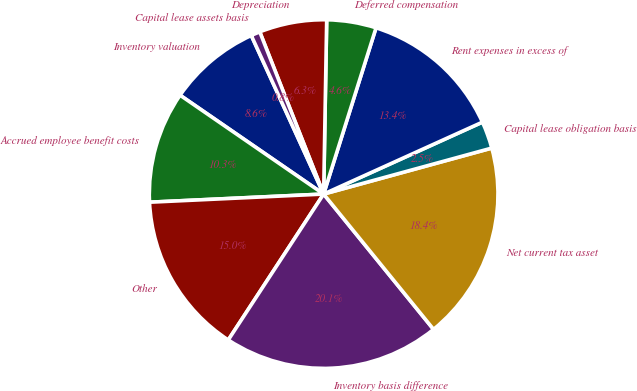<chart> <loc_0><loc_0><loc_500><loc_500><pie_chart><fcel>Inventory valuation<fcel>Accrued employee benefit costs<fcel>Other<fcel>Inventory basis difference<fcel>Net current tax asset<fcel>Capital lease obligation basis<fcel>Rent expenses in excess of<fcel>Deferred compensation<fcel>Depreciation<fcel>Capital lease assets basis<nl><fcel>8.59%<fcel>10.34%<fcel>15.04%<fcel>20.07%<fcel>18.39%<fcel>2.52%<fcel>13.37%<fcel>4.58%<fcel>6.25%<fcel>0.84%<nl></chart> 